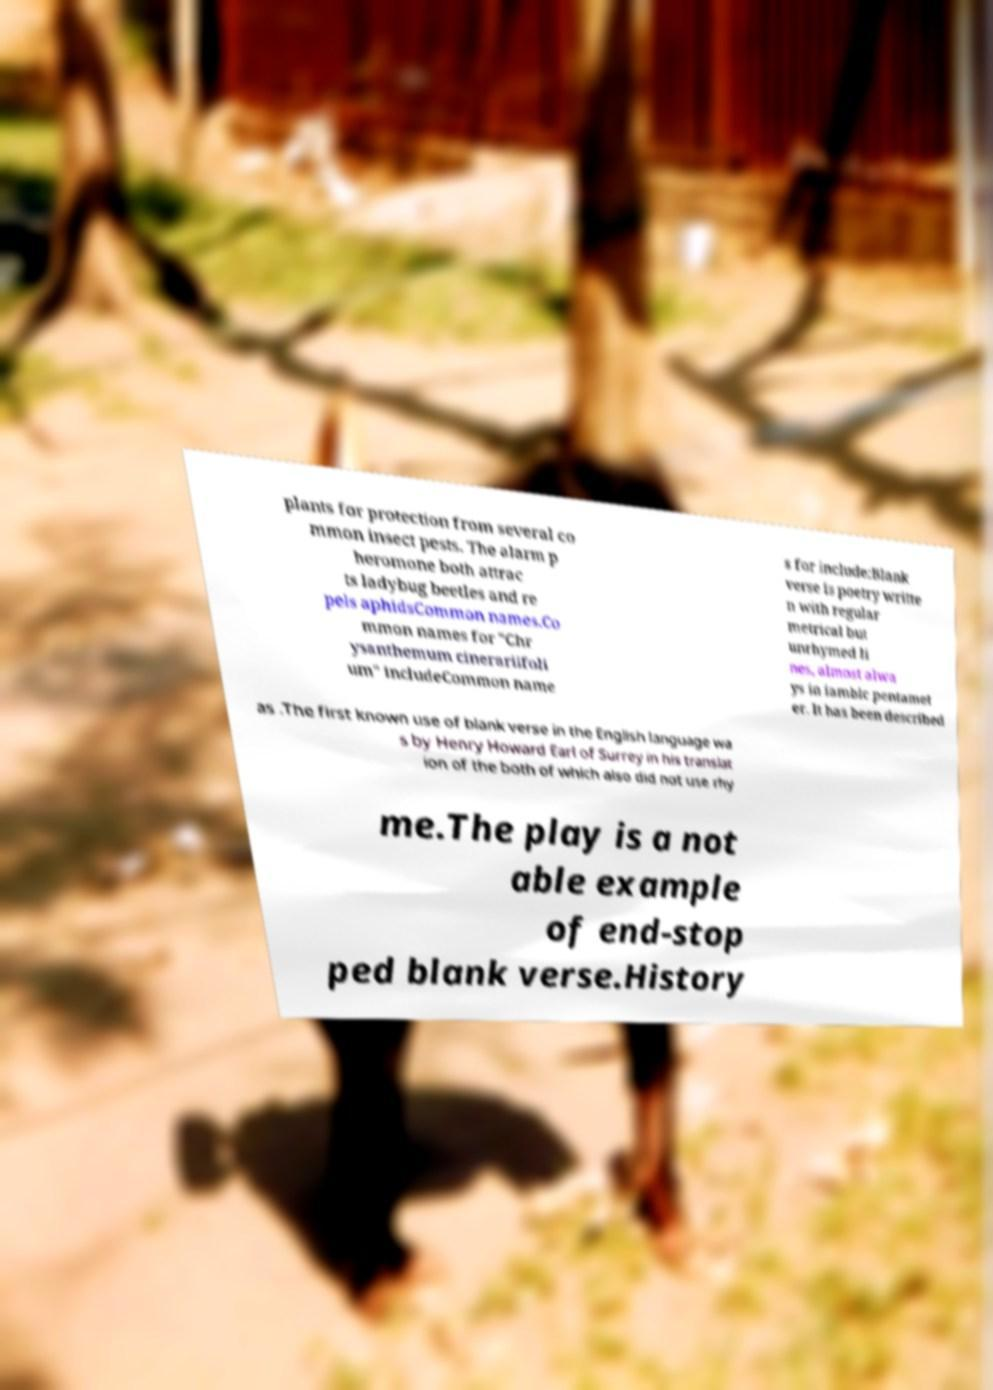Please identify and transcribe the text found in this image. plants for protection from several co mmon insect pests. The alarm p heromone both attrac ts ladybug beetles and re pels aphidsCommon names.Co mmon names for "Chr ysanthemum cinerariifoli um" includeCommon name s for include:Blank verse is poetry writte n with regular metrical but unrhymed li nes, almost alwa ys in iambic pentamet er. It has been described as .The first known use of blank verse in the English language wa s by Henry Howard Earl of Surrey in his translat ion of the both of which also did not use rhy me.The play is a not able example of end-stop ped blank verse.History 